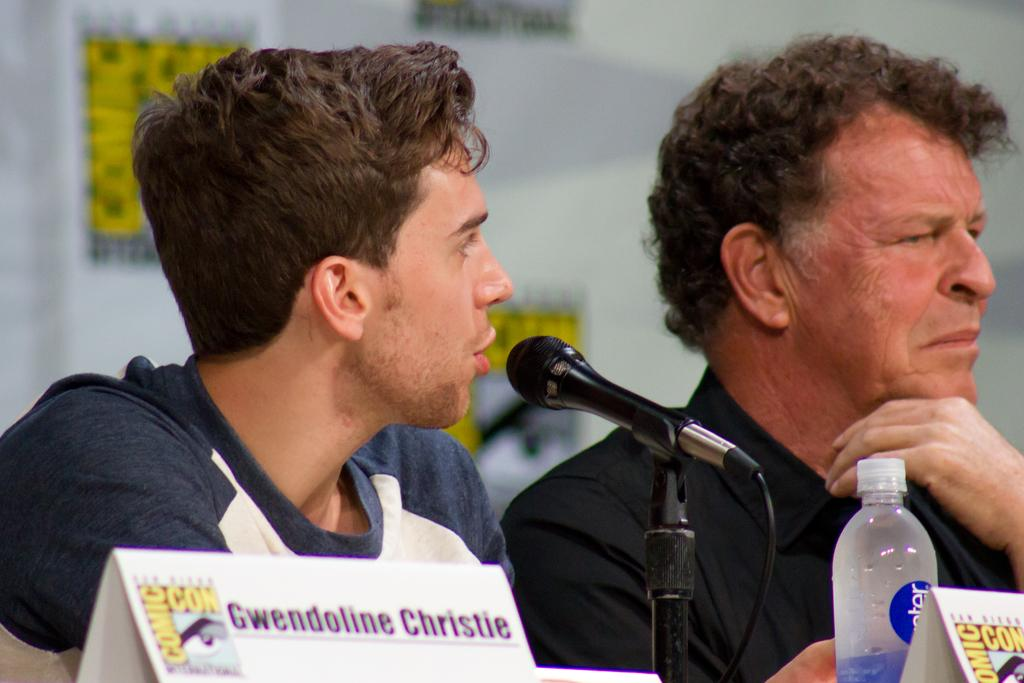How many people are present in the image? There are two persons sitting in the image. What is in front of the persons? There is a microphone and a water bottle in front of the persons. What can be seen in the background of the image? There is a wall in the background of the image. What type of fruit is on the table in the image? There is no table or fruit present in the image. 